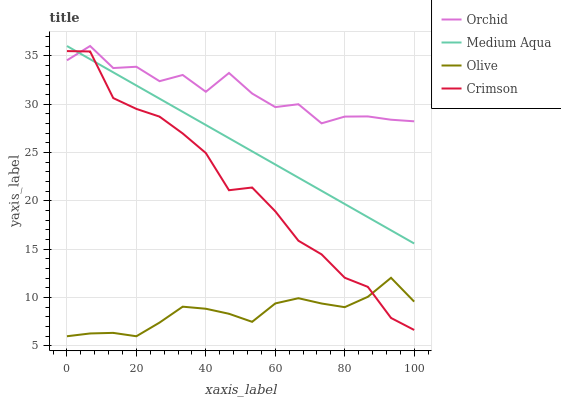Does Crimson have the minimum area under the curve?
Answer yes or no. No. Does Crimson have the maximum area under the curve?
Answer yes or no. No. Is Crimson the smoothest?
Answer yes or no. No. Is Crimson the roughest?
Answer yes or no. No. Does Crimson have the lowest value?
Answer yes or no. No. Does Crimson have the highest value?
Answer yes or no. No. Is Olive less than Medium Aqua?
Answer yes or no. Yes. Is Medium Aqua greater than Olive?
Answer yes or no. Yes. Does Olive intersect Medium Aqua?
Answer yes or no. No. 